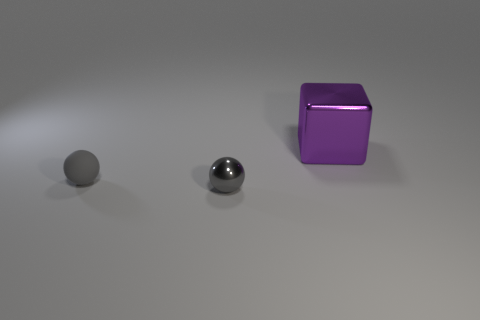Add 1 big brown cylinders. How many objects exist? 4 Subtract all blocks. How many objects are left? 2 Subtract 0 gray cylinders. How many objects are left? 3 Subtract all gray matte blocks. Subtract all gray objects. How many objects are left? 1 Add 3 big objects. How many big objects are left? 4 Add 1 gray spheres. How many gray spheres exist? 3 